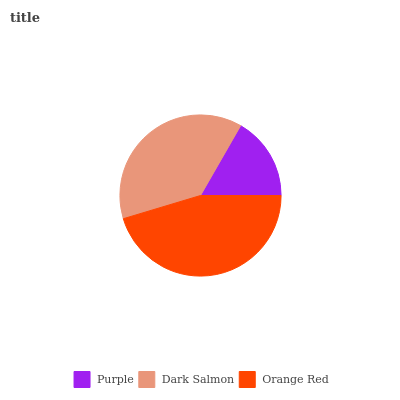Is Purple the minimum?
Answer yes or no. Yes. Is Orange Red the maximum?
Answer yes or no. Yes. Is Dark Salmon the minimum?
Answer yes or no. No. Is Dark Salmon the maximum?
Answer yes or no. No. Is Dark Salmon greater than Purple?
Answer yes or no. Yes. Is Purple less than Dark Salmon?
Answer yes or no. Yes. Is Purple greater than Dark Salmon?
Answer yes or no. No. Is Dark Salmon less than Purple?
Answer yes or no. No. Is Dark Salmon the high median?
Answer yes or no. Yes. Is Dark Salmon the low median?
Answer yes or no. Yes. Is Purple the high median?
Answer yes or no. No. Is Purple the low median?
Answer yes or no. No. 